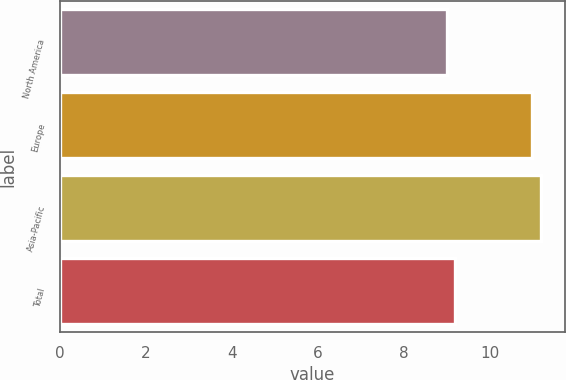Convert chart to OTSL. <chart><loc_0><loc_0><loc_500><loc_500><bar_chart><fcel>North America<fcel>Europe<fcel>Asia-Pacific<fcel>Total<nl><fcel>9<fcel>11<fcel>11.2<fcel>9.2<nl></chart> 